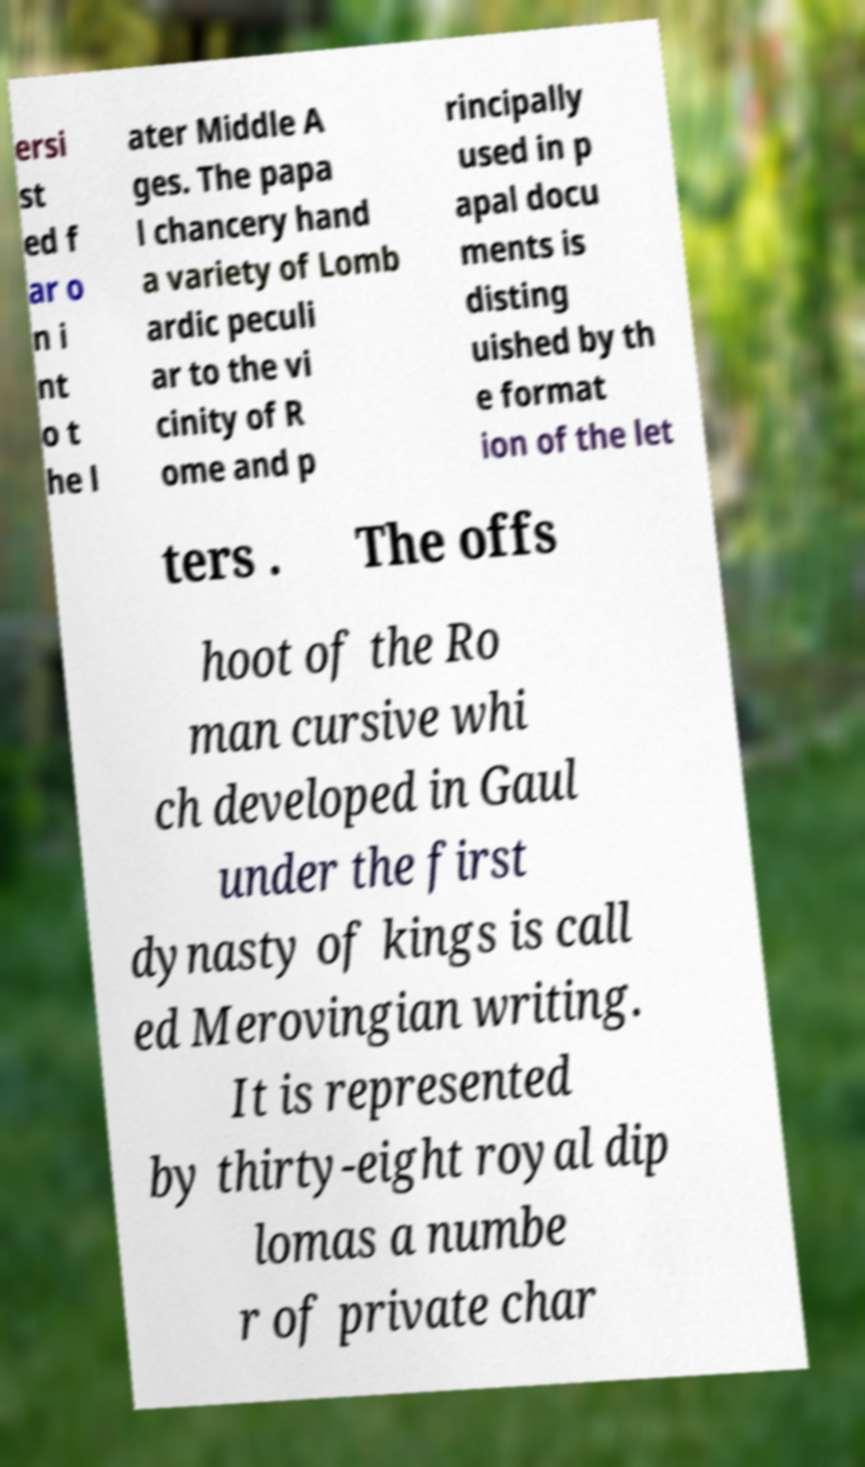Could you extract and type out the text from this image? ersi st ed f ar o n i nt o t he l ater Middle A ges. The papa l chancery hand a variety of Lomb ardic peculi ar to the vi cinity of R ome and p rincipally used in p apal docu ments is disting uished by th e format ion of the let ters . The offs hoot of the Ro man cursive whi ch developed in Gaul under the first dynasty of kings is call ed Merovingian writing. It is represented by thirty-eight royal dip lomas a numbe r of private char 